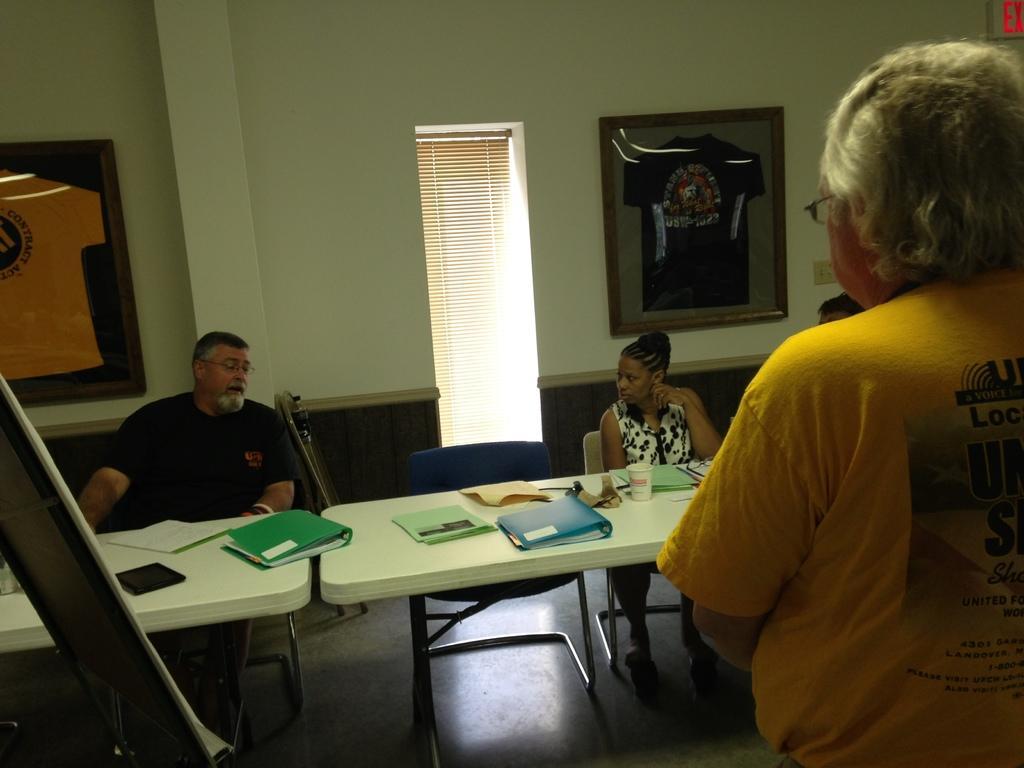Please provide a concise description of this image. In this picture there are few people who are sitting on the chair. There is a full, cup and an object on the table. There is a frame on the wall. There is a person standing. 